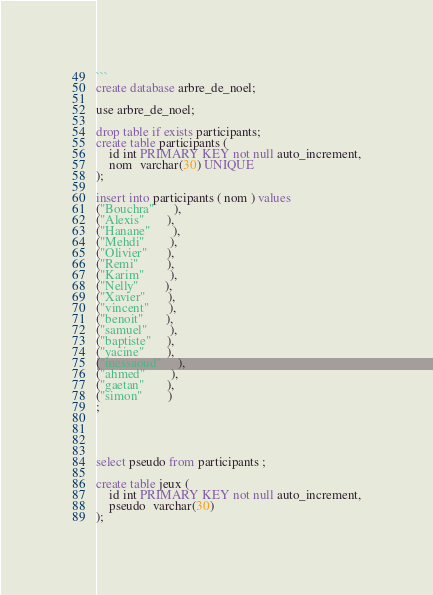Convert code to text. <code><loc_0><loc_0><loc_500><loc_500><_SQL_>```
create database arbre_de_noel;

use arbre_de_noel; 

drop table if exists participants;
create table participants (
    id int PRIMARY KEY not null auto_increment,
    nom  varchar(30) UNIQUE
);

insert into participants ( nom ) values
("Bouchra"      ),
("Alexis"       ),
("Hanane"       ),
("Mehdi"        ),
("Olivier"      ),
("Remi"         ),
("Karim"        ),
("Nelly"        ),
("Xavier"       ),
("vincent"      ), 
("benoit"       ), 
("samuel"       ), 
("baptiste"     ), 
("yacine"       ), 
("messaoud"     ), 
("ahmed"        ), 
("gaetan"       ), 
("simon"        )
;




select pseudo from participants ;

create table jeux (
    id int PRIMARY KEY not null auto_increment,
    pseudo  varchar(30)
);

</code> 